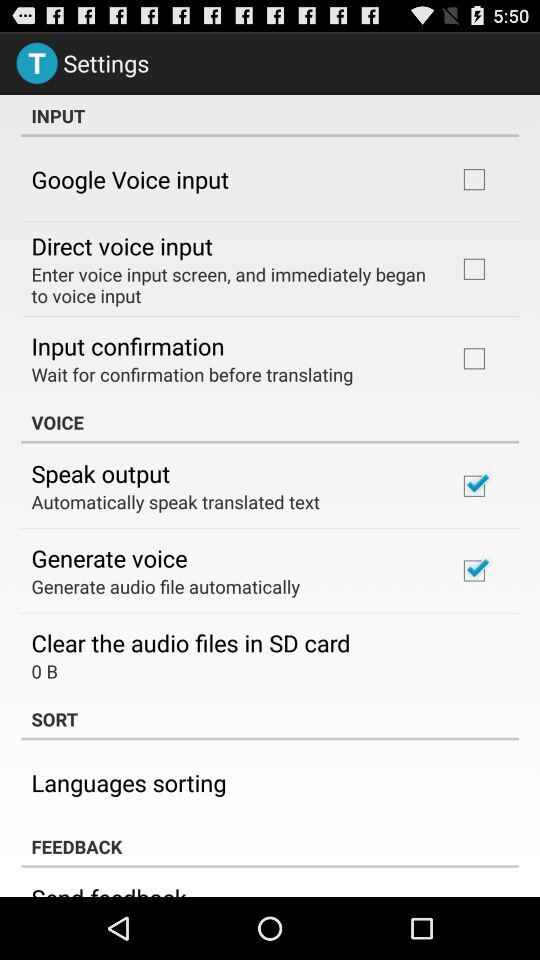What's the status of "Google Voice input"? The status of "Google Voice input" is "off". 